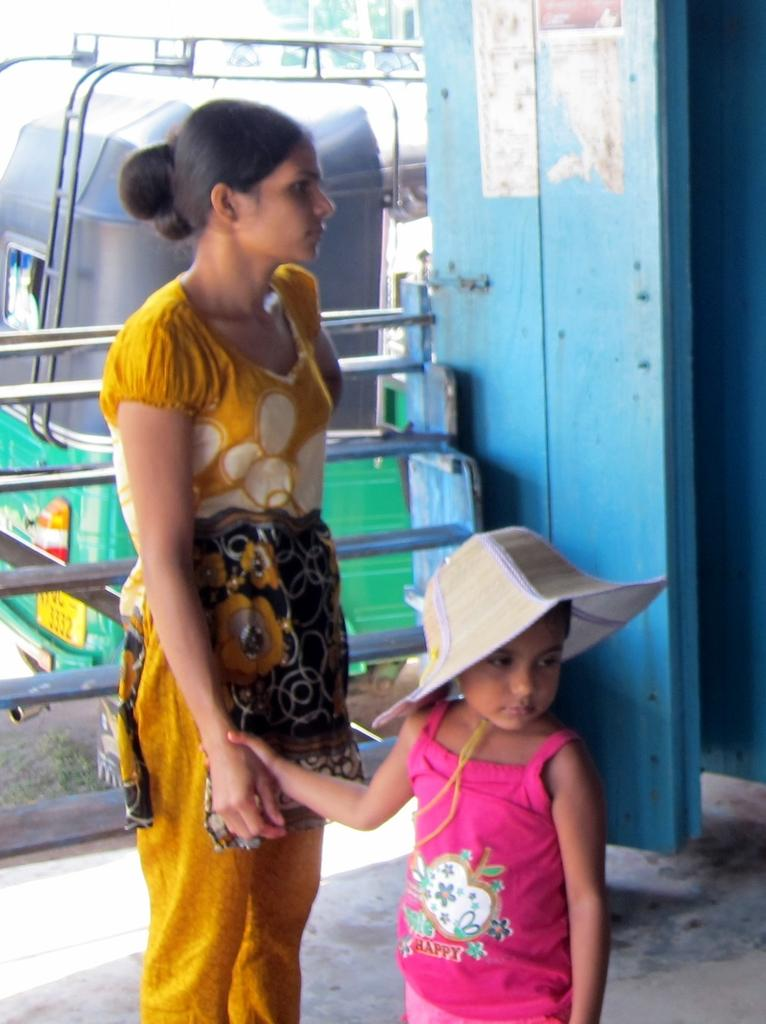Who is present in the image? There is a woman and a child in the image. What are the woman and child doing in the image? The woman and child are standing on the floor. What can be seen in the background of the image? There is an iron grill and a motor vehicle in the background of the image. What type of band is playing in the background of the image? A: There is no band present in the image; it only shows a woman and a child standing on the floor with an iron grill and a motor vehicle in the background. 